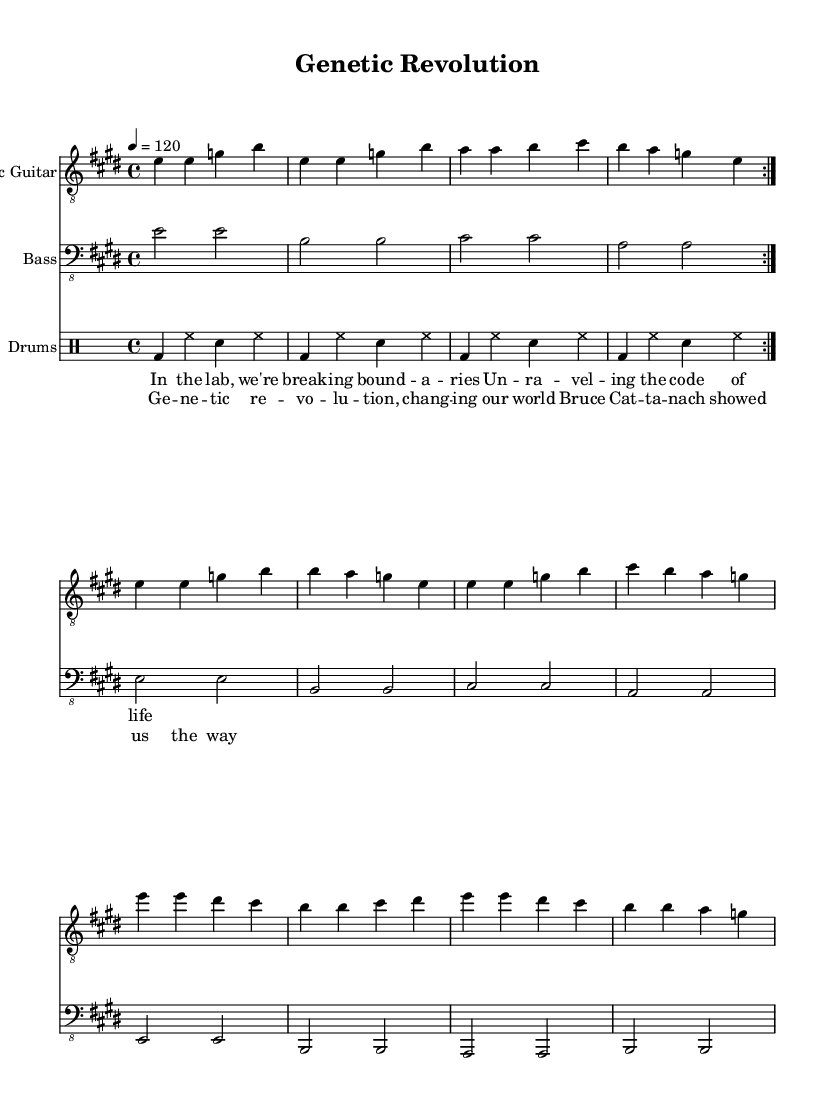What is the key signature of this music? The key signature is indicated at the beginning of the piece and shows three sharps, representing E major.
Answer: E major What is the time signature of this music? The time signature is shown at the start of the music and is defined as 4/4, which means there are four beats in each measure.
Answer: 4/4 What is the tempo marking for this piece? The tempo marking is indicated as "4 = 120," specifying the speed of the music at 120 beats per minute.
Answer: 120 Which instrument plays the main riff at the beginning? The main riff is played by the electric guitar as indicated at the beginning of the staff labeled "Electric Guitar."
Answer: Electric Guitar How many bars are in the chorus section? To find the number of bars in the chorus, count each measure in the chorus part, which shows a total of four measures.
Answer: 4 What is the lyrical theme of the verse? The lyrics discuss breaking boundaries in the lab and unraveling the code of life, reflecting themes of scientific discovery.
Answer: Scientific discovery What is the rhythmic pattern used by the drums? The drums follow a basic rock beat pattern that involves a combination of bass drum, hi-hat, and snare across the repeated volta of the music.
Answer: Basic rock beat 